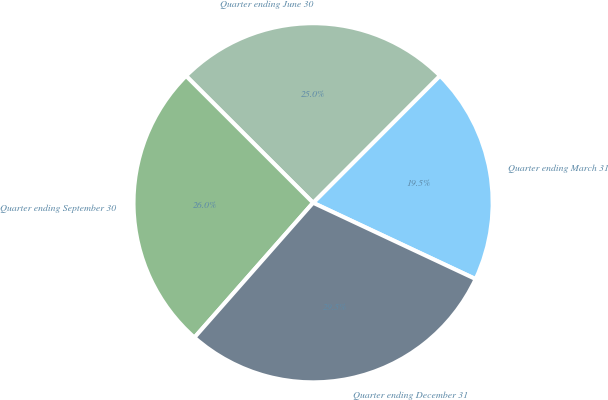Convert chart to OTSL. <chart><loc_0><loc_0><loc_500><loc_500><pie_chart><fcel>Quarter ending March 31<fcel>Quarter ending June 30<fcel>Quarter ending September 30<fcel>Quarter ending December 31<nl><fcel>19.5%<fcel>25.0%<fcel>26.0%<fcel>29.51%<nl></chart> 